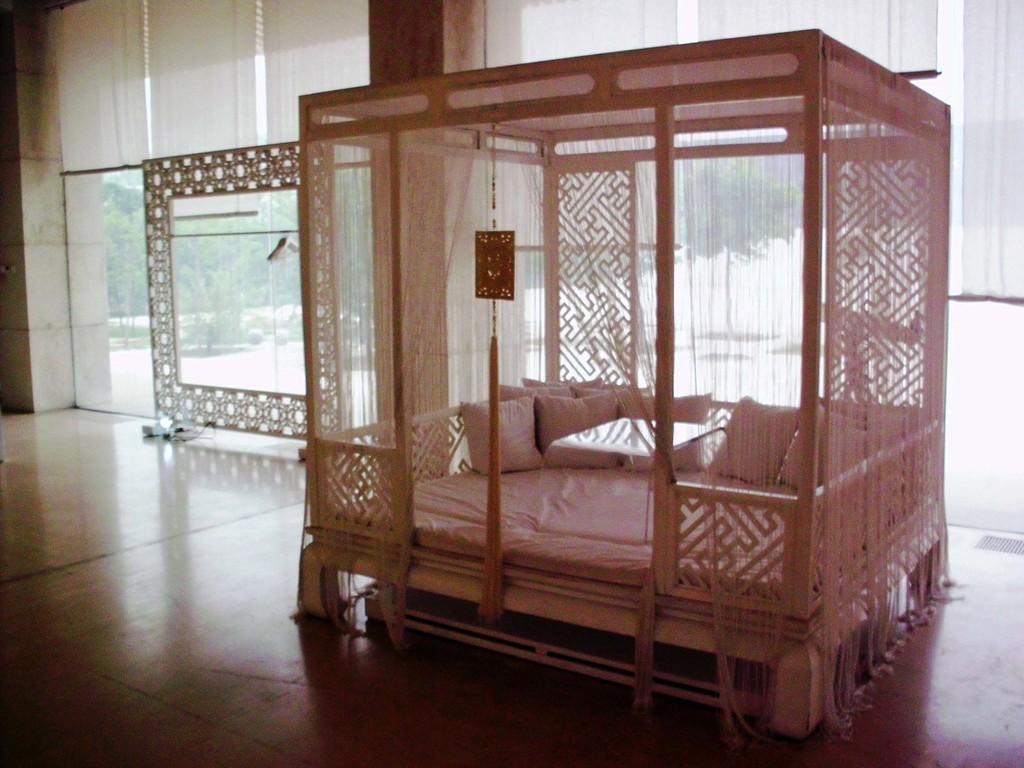Could you give a brief overview of what you see in this image? In this image, I can see a four poster divan with cushions, table, curtains and an object. On the left side of the image, I can see a frame on the floor. In the background, there are white curtains and I can see trees through the glass doors. 